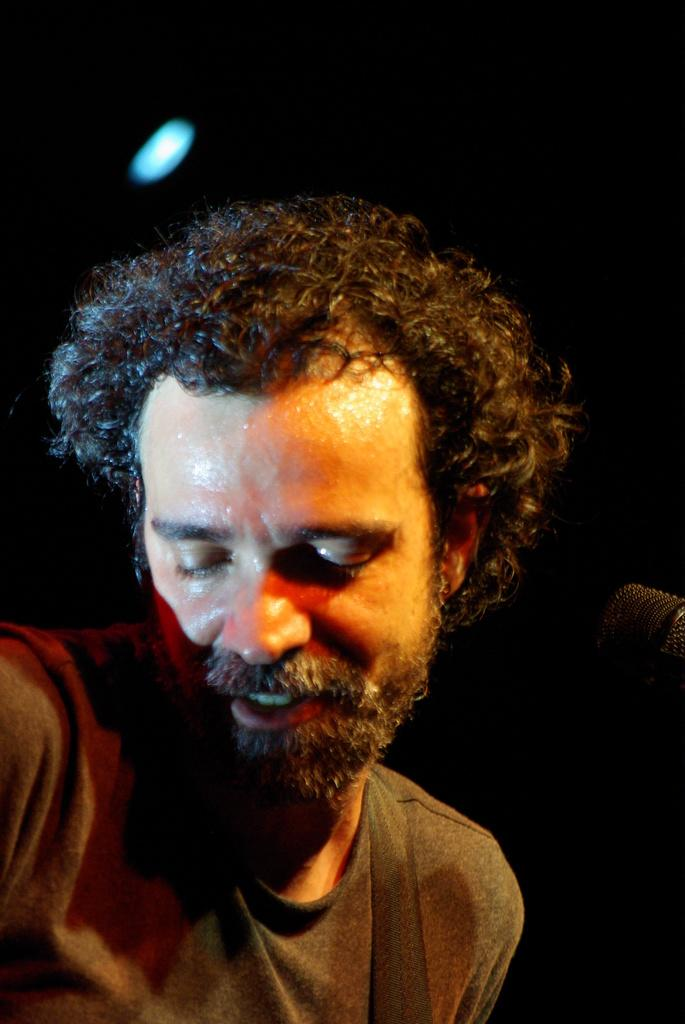Who is present in the image? There is a man in the image. What can be observed about the background of the image? The background of the image is dark. What type of knife is being used by the man in the image? There is no knife present in the image; only a man and a dark background are visible. 